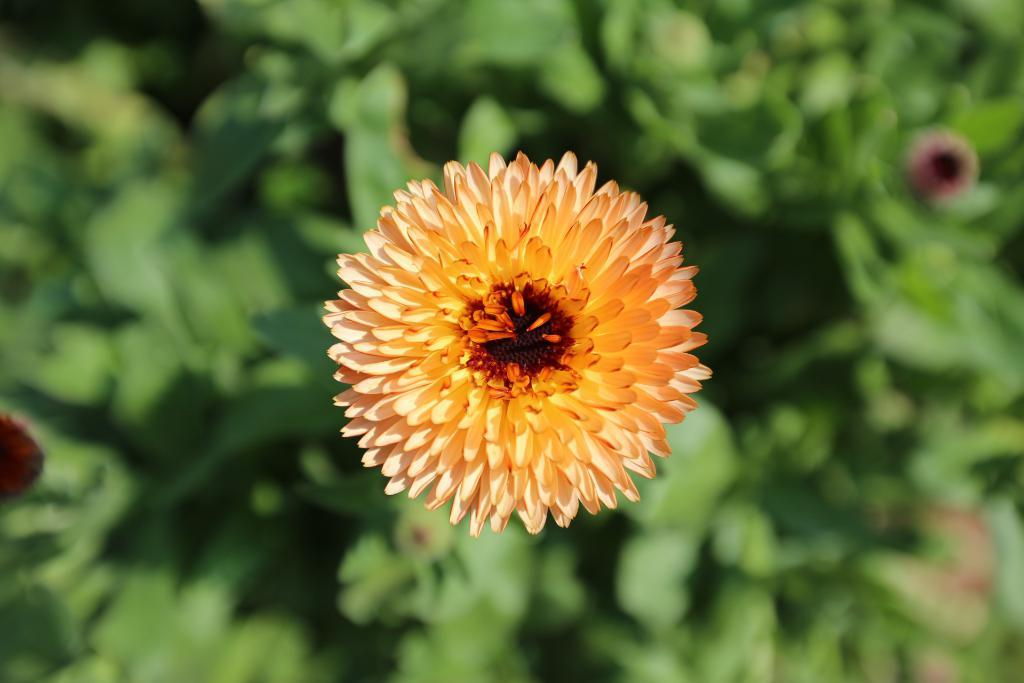What is the main subject in the foreground of the image? There is a flower in the foreground of the image. What can be observed about the background of the image? The background of the image is blurry. Can you tell me how many experts are present in the image? There are no experts present in the image; it features a flower in the foreground and a blurry background. What type of train can be seen in the image? There is no train present in the image. 